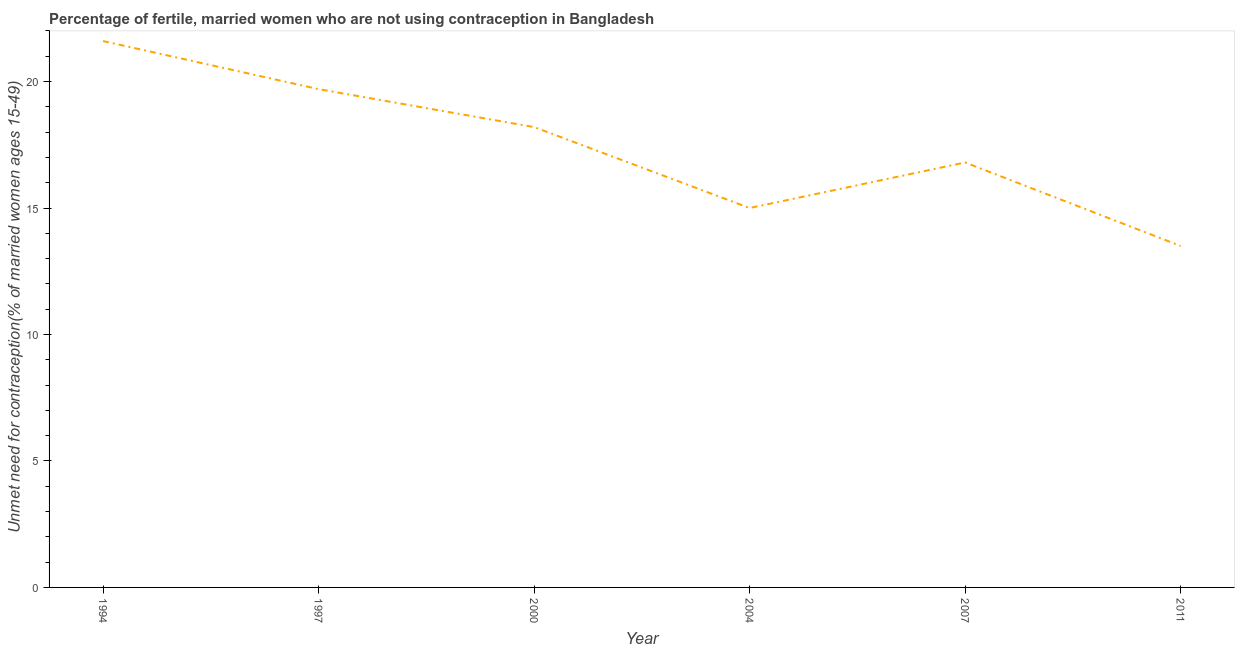What is the number of married women who are not using contraception in 2000?
Provide a short and direct response. 18.2. Across all years, what is the maximum number of married women who are not using contraception?
Make the answer very short. 21.6. In which year was the number of married women who are not using contraception maximum?
Offer a terse response. 1994. In which year was the number of married women who are not using contraception minimum?
Your response must be concise. 2011. What is the sum of the number of married women who are not using contraception?
Keep it short and to the point. 104.8. What is the difference between the number of married women who are not using contraception in 2000 and 2011?
Offer a very short reply. 4.7. What is the average number of married women who are not using contraception per year?
Your response must be concise. 17.47. What is the median number of married women who are not using contraception?
Ensure brevity in your answer.  17.5. Do a majority of the years between 2011 and 2004 (inclusive) have number of married women who are not using contraception greater than 19 %?
Ensure brevity in your answer.  No. What is the ratio of the number of married women who are not using contraception in 1997 to that in 2011?
Your answer should be compact. 1.46. Is the number of married women who are not using contraception in 1994 less than that in 2011?
Make the answer very short. No. What is the difference between the highest and the second highest number of married women who are not using contraception?
Offer a terse response. 1.9. What is the difference between the highest and the lowest number of married women who are not using contraception?
Provide a succinct answer. 8.1. How many lines are there?
Provide a succinct answer. 1. How many years are there in the graph?
Offer a very short reply. 6. Are the values on the major ticks of Y-axis written in scientific E-notation?
Provide a succinct answer. No. What is the title of the graph?
Provide a succinct answer. Percentage of fertile, married women who are not using contraception in Bangladesh. What is the label or title of the X-axis?
Your answer should be very brief. Year. What is the label or title of the Y-axis?
Provide a short and direct response.  Unmet need for contraception(% of married women ages 15-49). What is the  Unmet need for contraception(% of married women ages 15-49) of 1994?
Provide a succinct answer. 21.6. What is the  Unmet need for contraception(% of married women ages 15-49) in 2000?
Provide a short and direct response. 18.2. What is the  Unmet need for contraception(% of married women ages 15-49) in 2004?
Offer a very short reply. 15. What is the  Unmet need for contraception(% of married women ages 15-49) in 2011?
Make the answer very short. 13.5. What is the difference between the  Unmet need for contraception(% of married women ages 15-49) in 1994 and 2000?
Offer a very short reply. 3.4. What is the difference between the  Unmet need for contraception(% of married women ages 15-49) in 1994 and 2004?
Provide a succinct answer. 6.6. What is the difference between the  Unmet need for contraception(% of married women ages 15-49) in 1994 and 2007?
Provide a short and direct response. 4.8. What is the difference between the  Unmet need for contraception(% of married women ages 15-49) in 1997 and 2004?
Your answer should be compact. 4.7. What is the difference between the  Unmet need for contraception(% of married women ages 15-49) in 1997 and 2011?
Provide a succinct answer. 6.2. What is the difference between the  Unmet need for contraception(% of married women ages 15-49) in 2000 and 2011?
Give a very brief answer. 4.7. What is the difference between the  Unmet need for contraception(% of married women ages 15-49) in 2004 and 2011?
Make the answer very short. 1.5. What is the difference between the  Unmet need for contraception(% of married women ages 15-49) in 2007 and 2011?
Your response must be concise. 3.3. What is the ratio of the  Unmet need for contraception(% of married women ages 15-49) in 1994 to that in 1997?
Your answer should be very brief. 1.1. What is the ratio of the  Unmet need for contraception(% of married women ages 15-49) in 1994 to that in 2000?
Provide a short and direct response. 1.19. What is the ratio of the  Unmet need for contraception(% of married women ages 15-49) in 1994 to that in 2004?
Ensure brevity in your answer.  1.44. What is the ratio of the  Unmet need for contraception(% of married women ages 15-49) in 1994 to that in 2007?
Your response must be concise. 1.29. What is the ratio of the  Unmet need for contraception(% of married women ages 15-49) in 1997 to that in 2000?
Provide a succinct answer. 1.08. What is the ratio of the  Unmet need for contraception(% of married women ages 15-49) in 1997 to that in 2004?
Your answer should be very brief. 1.31. What is the ratio of the  Unmet need for contraception(% of married women ages 15-49) in 1997 to that in 2007?
Your answer should be very brief. 1.17. What is the ratio of the  Unmet need for contraception(% of married women ages 15-49) in 1997 to that in 2011?
Offer a very short reply. 1.46. What is the ratio of the  Unmet need for contraception(% of married women ages 15-49) in 2000 to that in 2004?
Provide a succinct answer. 1.21. What is the ratio of the  Unmet need for contraception(% of married women ages 15-49) in 2000 to that in 2007?
Offer a terse response. 1.08. What is the ratio of the  Unmet need for contraception(% of married women ages 15-49) in 2000 to that in 2011?
Your answer should be very brief. 1.35. What is the ratio of the  Unmet need for contraception(% of married women ages 15-49) in 2004 to that in 2007?
Provide a succinct answer. 0.89. What is the ratio of the  Unmet need for contraception(% of married women ages 15-49) in 2004 to that in 2011?
Your answer should be compact. 1.11. What is the ratio of the  Unmet need for contraception(% of married women ages 15-49) in 2007 to that in 2011?
Ensure brevity in your answer.  1.24. 